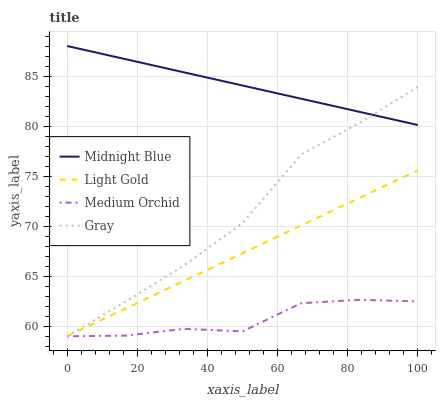Does Medium Orchid have the minimum area under the curve?
Answer yes or no. Yes. Does Midnight Blue have the maximum area under the curve?
Answer yes or no. Yes. Does Light Gold have the minimum area under the curve?
Answer yes or no. No. Does Light Gold have the maximum area under the curve?
Answer yes or no. No. Is Light Gold the smoothest?
Answer yes or no. Yes. Is Medium Orchid the roughest?
Answer yes or no. Yes. Is Medium Orchid the smoothest?
Answer yes or no. No. Is Light Gold the roughest?
Answer yes or no. No. Does Gray have the lowest value?
Answer yes or no. Yes. Does Midnight Blue have the lowest value?
Answer yes or no. No. Does Midnight Blue have the highest value?
Answer yes or no. Yes. Does Light Gold have the highest value?
Answer yes or no. No. Is Medium Orchid less than Midnight Blue?
Answer yes or no. Yes. Is Midnight Blue greater than Medium Orchid?
Answer yes or no. Yes. Does Medium Orchid intersect Light Gold?
Answer yes or no. Yes. Is Medium Orchid less than Light Gold?
Answer yes or no. No. Is Medium Orchid greater than Light Gold?
Answer yes or no. No. Does Medium Orchid intersect Midnight Blue?
Answer yes or no. No. 